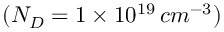<formula> <loc_0><loc_0><loc_500><loc_500>( N _ { D } = 1 \times 1 0 ^ { 1 9 } \, c m ^ { - 3 } )</formula> 